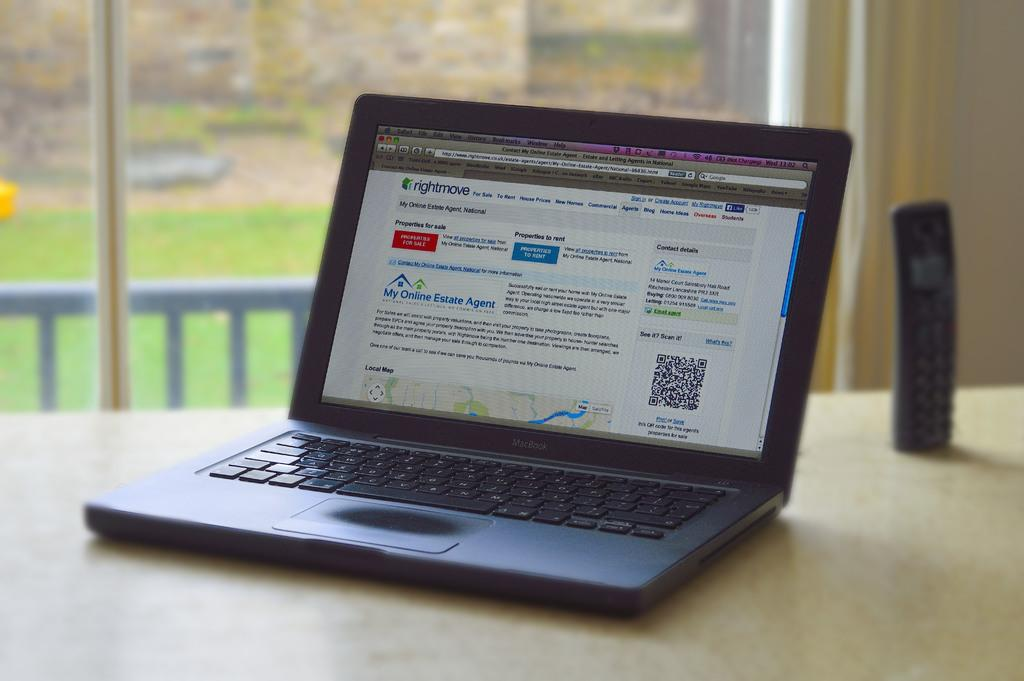Provide a one-sentence caption for the provided image. An open lap top with my online estate agent written on the screen. 